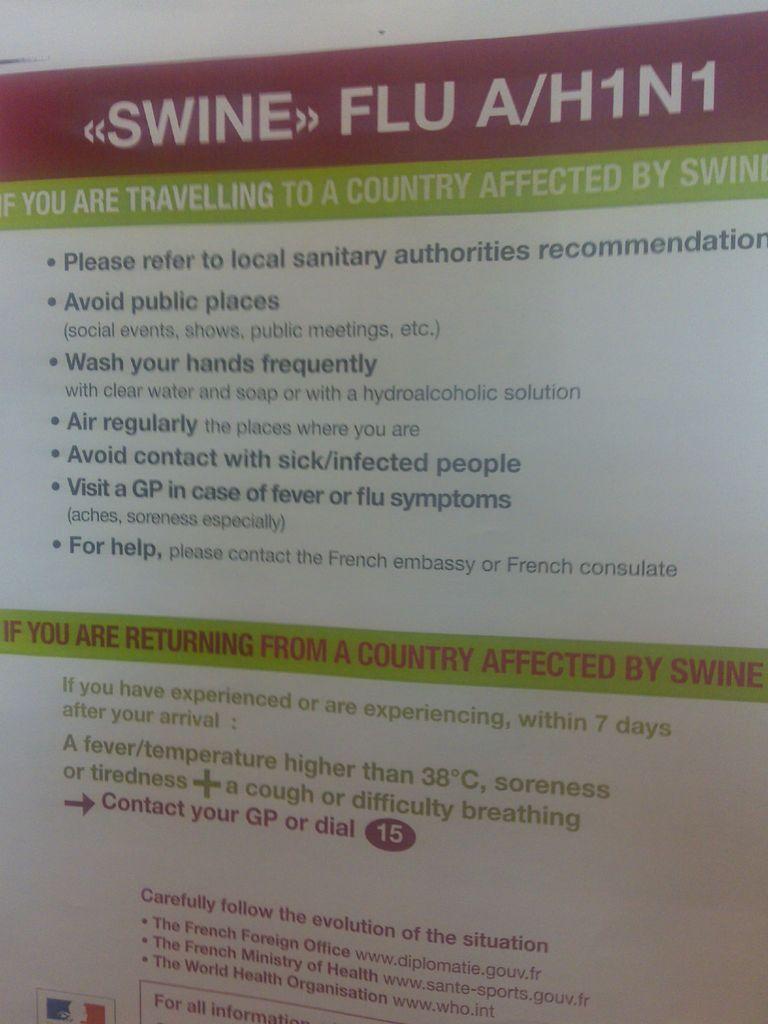What kind of flu is being warned about?
Ensure brevity in your answer.  Swine. Does it say to avoid what kind of places?
Make the answer very short. Public. 